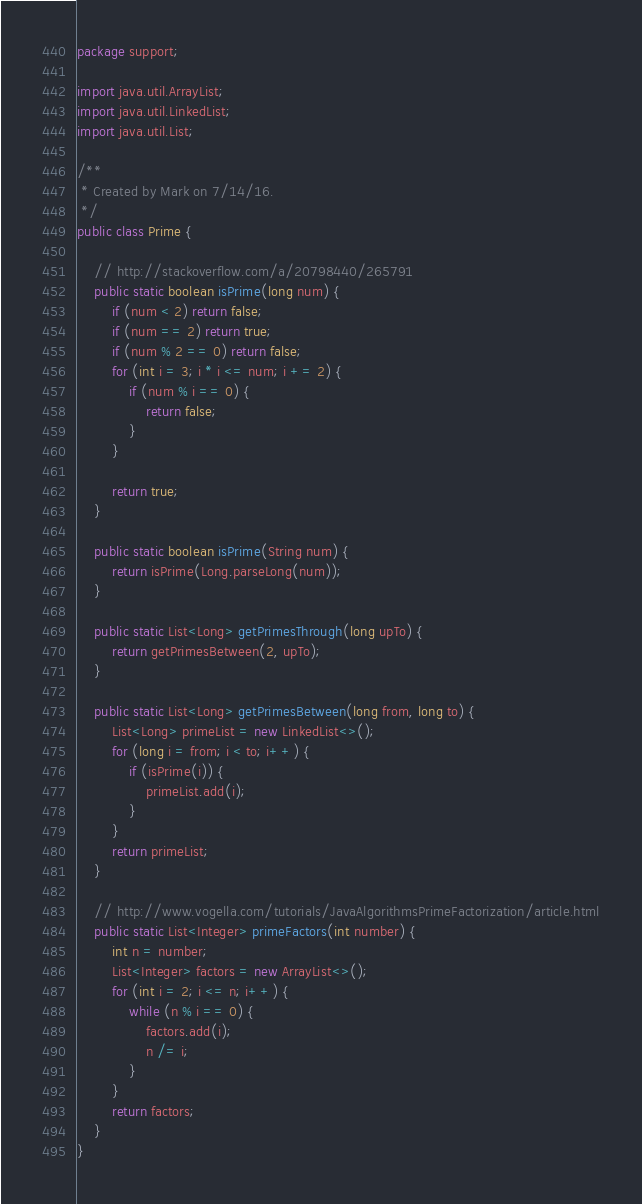<code> <loc_0><loc_0><loc_500><loc_500><_Java_>package support;

import java.util.ArrayList;
import java.util.LinkedList;
import java.util.List;

/**
 * Created by Mark on 7/14/16.
 */
public class Prime {

    // http://stackoverflow.com/a/20798440/265791
    public static boolean isPrime(long num) {
        if (num < 2) return false;
        if (num == 2) return true;
        if (num % 2 == 0) return false;
        for (int i = 3; i * i <= num; i += 2) {
            if (num % i == 0) {
                return false;
            }
        }

        return true;
    }

    public static boolean isPrime(String num) {
        return isPrime(Long.parseLong(num));
    }

    public static List<Long> getPrimesThrough(long upTo) {
        return getPrimesBetween(2, upTo);
    }

    public static List<Long> getPrimesBetween(long from, long to) {
        List<Long> primeList = new LinkedList<>();
        for (long i = from; i < to; i++) {
            if (isPrime(i)) {
                primeList.add(i);
            }
        }
        return primeList;
    }

    // http://www.vogella.com/tutorials/JavaAlgorithmsPrimeFactorization/article.html
    public static List<Integer> primeFactors(int number) {
        int n = number;
        List<Integer> factors = new ArrayList<>();
        for (int i = 2; i <= n; i++) {
            while (n % i == 0) {
                factors.add(i);
                n /= i;
            }
        }
        return factors;
    }
}
</code> 